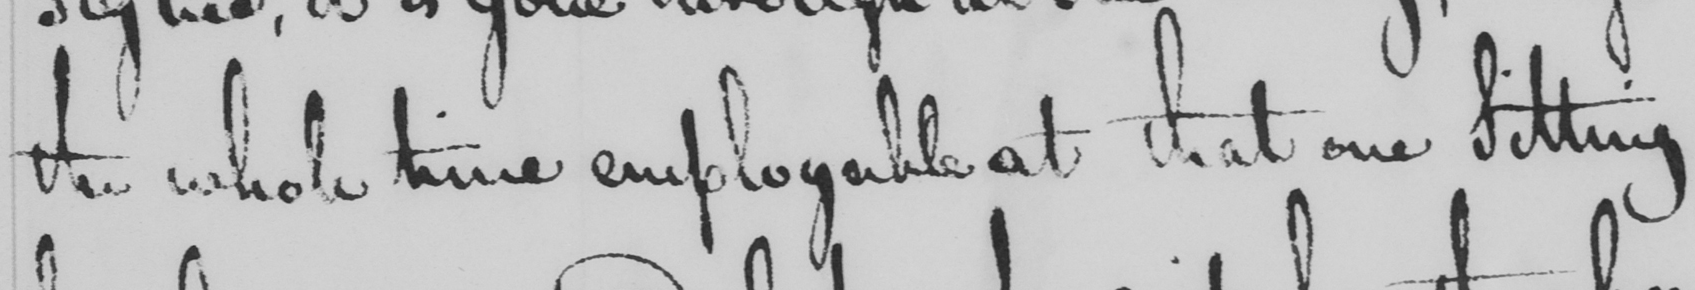Can you tell me what this handwritten text says? the whole time employable at that one Sitting 